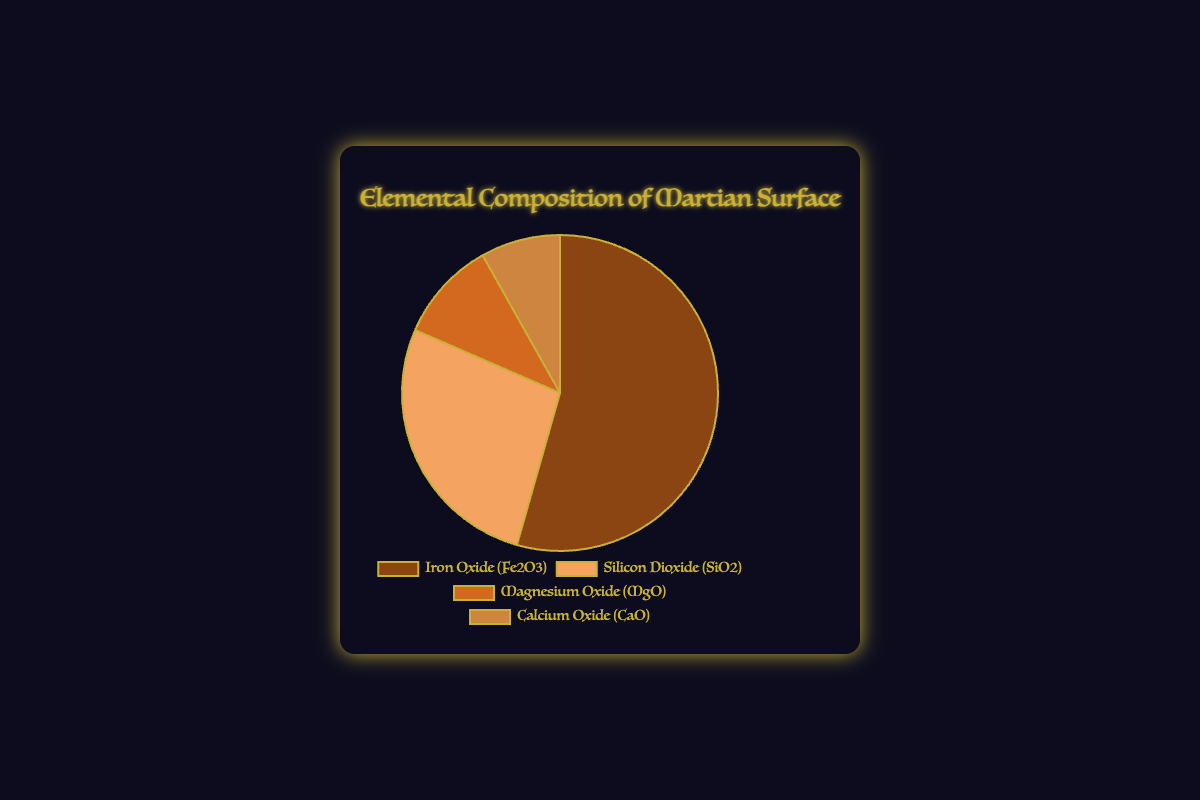What is the element with the highest percentage in the Martian surface composition? By looking at the pie chart, the largest section corresponds to Iron Oxide (Fe2O3) with a percentage of 42.7%.
Answer: Iron Oxide (Fe2O3) Which element has the second highest percentage in the Martian surface composition? The second largest section in the pie chart represents Silicon Dioxide (SiO2) with a value of 21.3%.
Answer: Silicon Dioxide (SiO2) What is the total percentage of Iron Oxide (Fe2O3) and Silicon Dioxide (SiO2) combined? Adding the percentages of Iron Oxide (42.7%) and Silicon Dioxide (21.3%) gives 42.7 + 21.3 = 64.
Answer: 64% What is the difference in percentage between Magnesium Oxide (MgO) and Calcium Oxide (CaO)? Subtract the percentage of Calcium Oxide (6.4%) from Magnesium Oxide (8.1%) to get 8.1 - 6.4 = 1.7.
Answer: 1.7% What is the average percentage of all four elements in the Martian surface composition? Sum the percentages of all four elements (42.7 + 21.3 + 8.1 + 6.4) and divide by 4. The total is 78.5 and 78.5 / 4 = 19.625.
Answer: 19.625% Which section of the pie chart is represented with a brownish color? By looking at the pie chart, the section represented with a brownish color corresponds to Iron Oxide (Fe2O3).
Answer: Iron Oxide (Fe2O3) If Iron Oxide (Fe2O3) and Silicon Dioxide (SiO2) together form more than half of the entire pie chart, what is their combined percentage as a ratio of the whole? Iron Oxide (42.7%) and Silicon Dioxide (21.3%) combined make up 64%. This is more than half of 100%, so their ratio is 64%.
Answer: 64% Which element covers the smallest portion of the pie chart? The smallest portion of the pie chart is occupied by Calcium Oxide (CaO) with a percentage of 6.4%.
Answer: Calcium Oxide (CaO) How many elements make up less than 10% of the Martian surface composition? By referring to the pie chart, both Magnesium Oxide (8.1%) and Calcium Oxide (6.4%) are under 10%; thus, two elements meet this criterion.
Answer: 2 What is the combined percentage of Magnesium Oxide (MgO) and Calcium Oxide (CaO)? Adding the percentages of Magnesium Oxide (8.1%) and Calcium Oxide (6.4%) gives 8.1 + 6.4 = 14.5.
Answer: 14.5% 